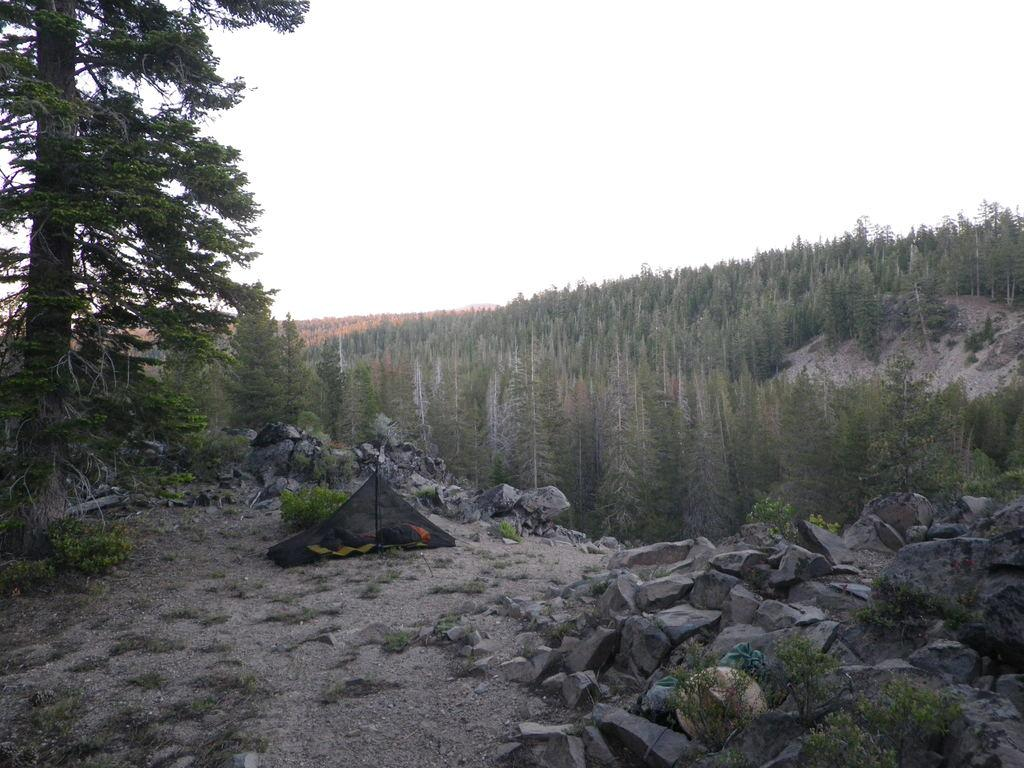What type of natural elements can be seen in the image? There are trees, plants, and rocks visible in the image. What type of shelter is present in the image? There is a tent in the image. What geographical feature is present in the image? There is a mountain in the image. What part of the natural environment is visible in the image? The sky is visible in the image. What type of books can be seen on the ship in the image? There is no ship present in the image, and therefore no books can be seen on it. 